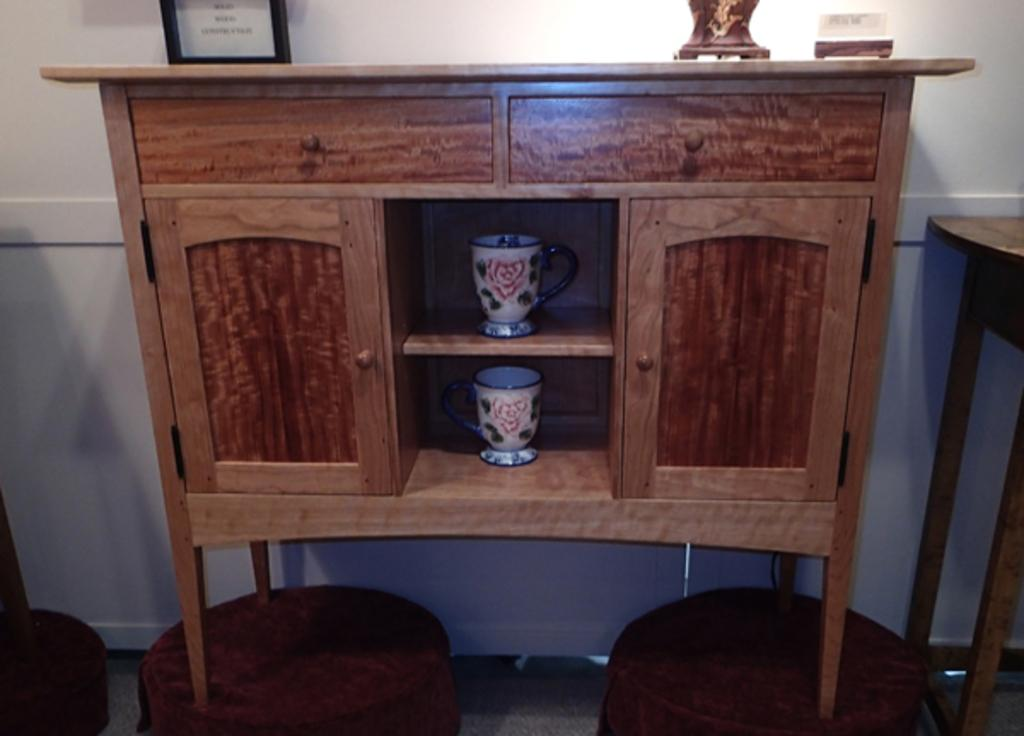What is the color of the cupboards in the image? The cupboards in the image are brown. How many mugs can be seen in the image? There are two mugs placed in the racks in the image. What is placed on the desk in the image? There is a photo frame placed on the desk in the image. What is visible in the background of the image? There is a wall in the background of the image. What type of roll is being prepared on the desk in the image? There is no roll being prepared in the image; the focus is on the cupboards, mugs, and photo frame. Can you tell me the plot of the story depicted in the photo frame? There is no story depicted in the photo frame in the image; it is simply a photo or image. 